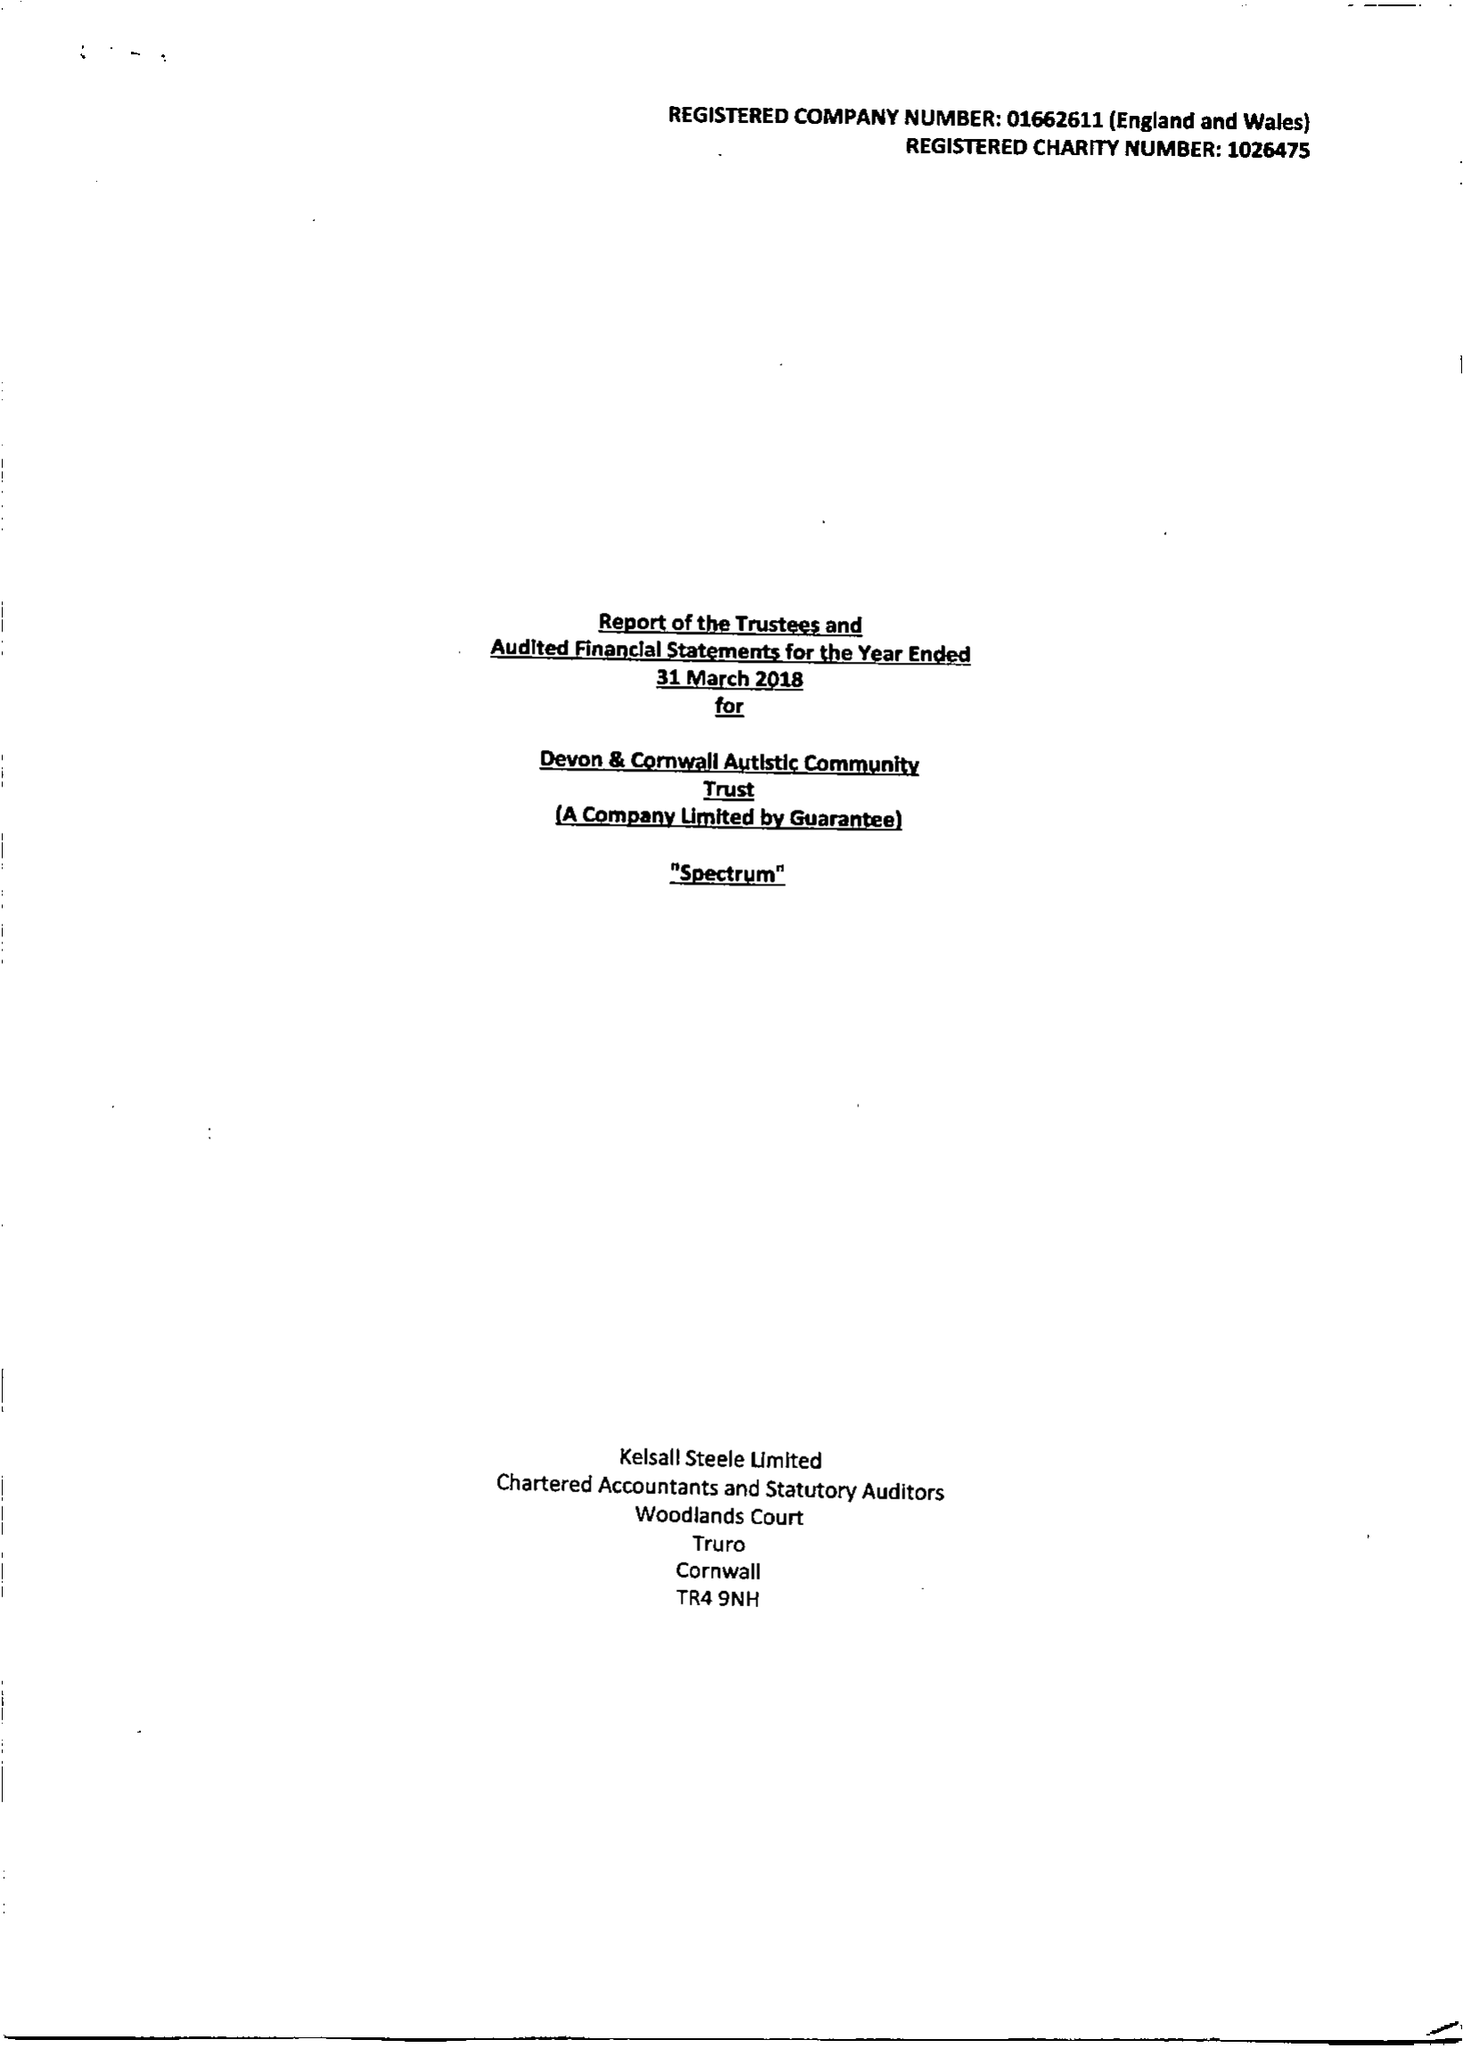What is the value for the address__postcode?
Answer the question using a single word or phrase. TR13 0SR 